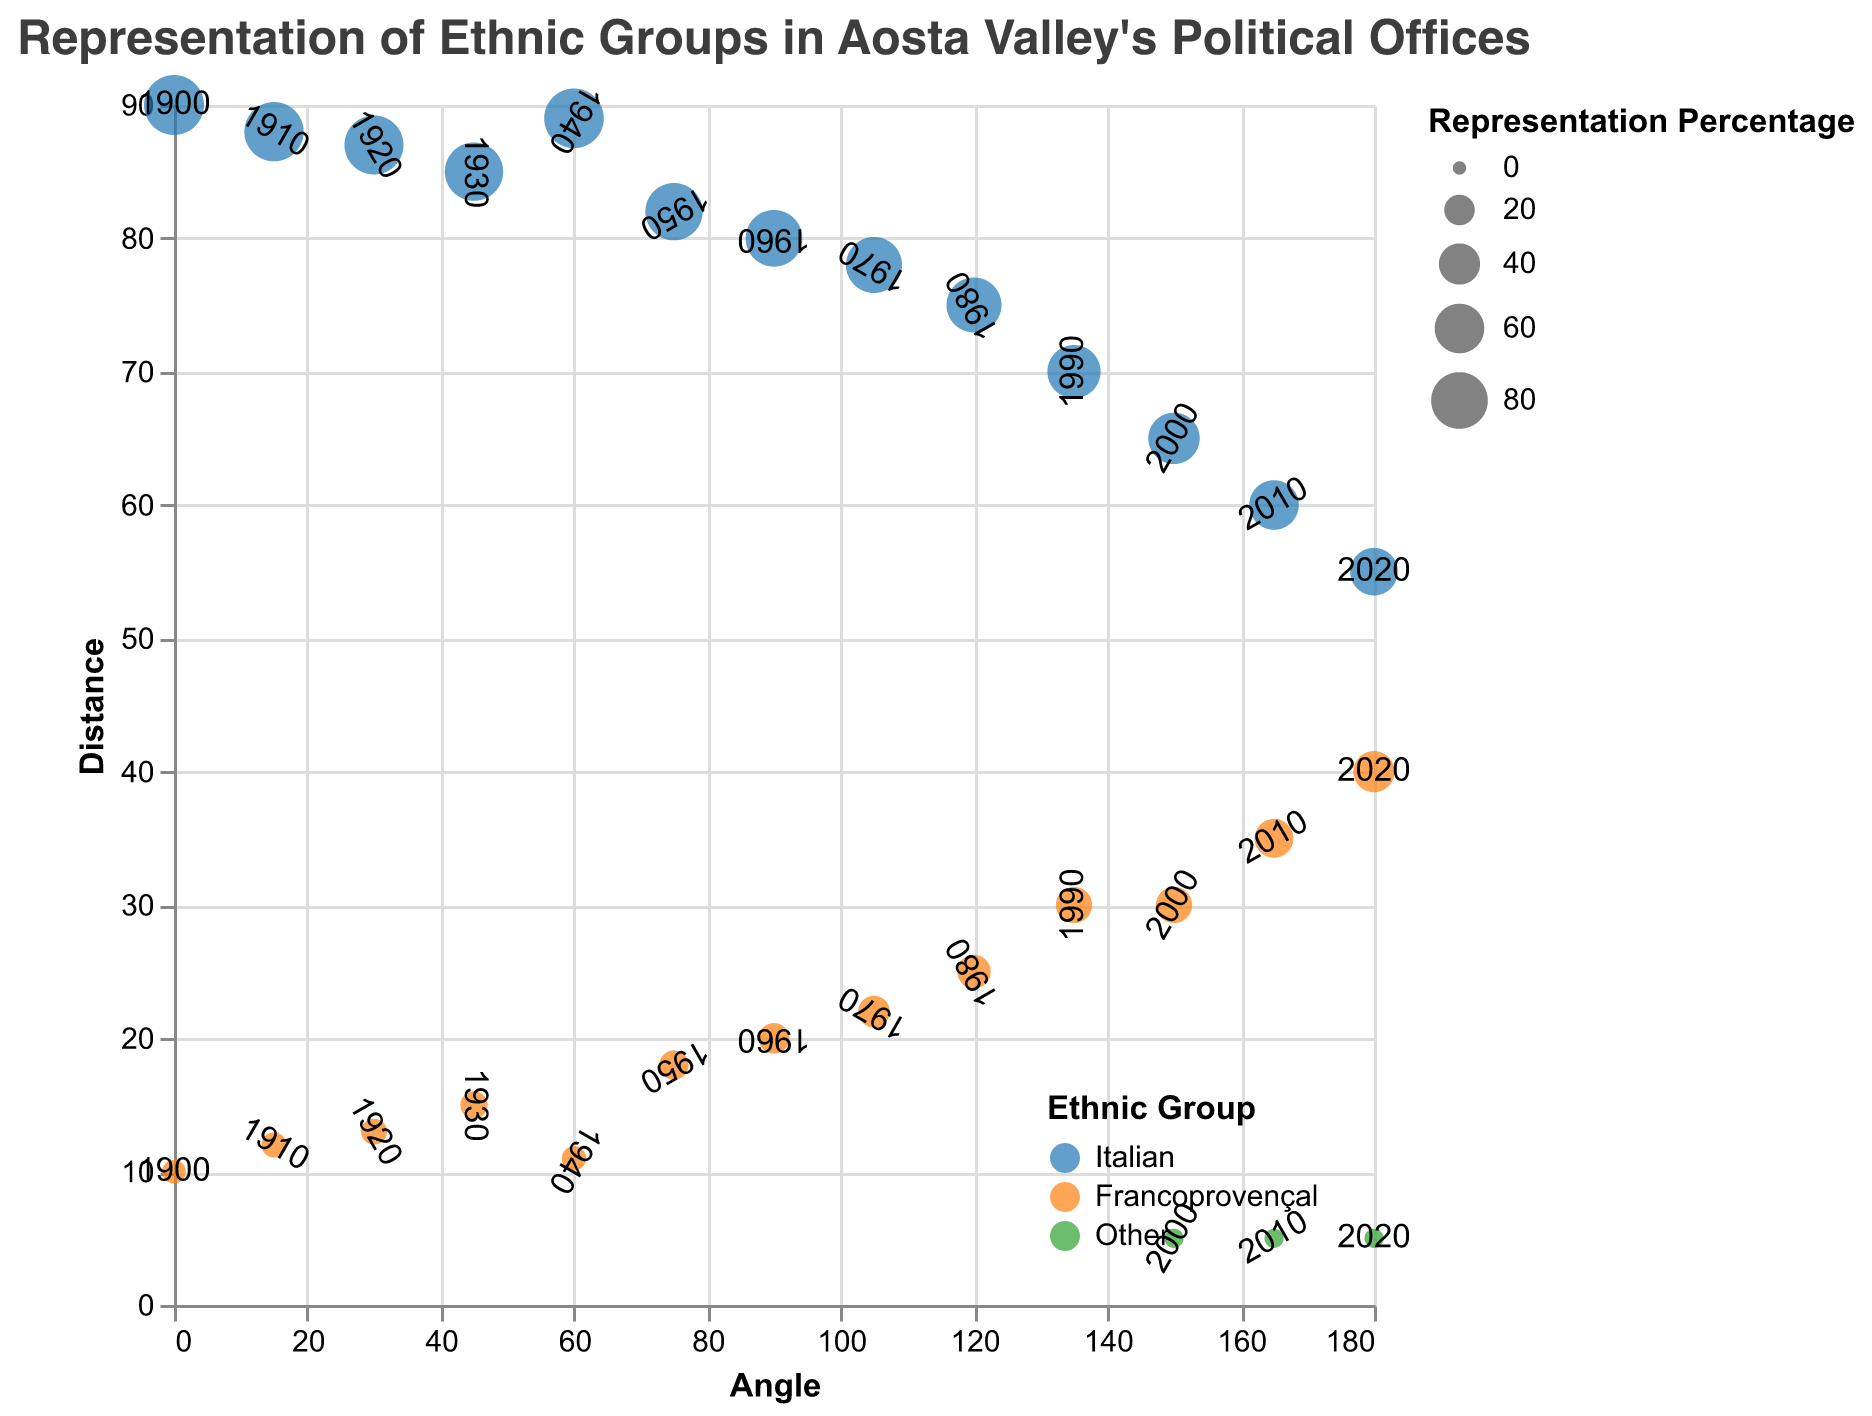What ethnic group had the highest representation percentage in 1900? Look at the data points at the angle corresponding to 1900 and identify the ethnic group with the highest distance from the origin. The Italian group is at 90%, while Francoprovençal is at 10%.
Answer: Italian How did the representation percentage of Francoprovençal change from 1960 to 2020? Examine the data points at the angles corresponding to 1960 and 2020. In 1960, the Francoprovençal group had 20%, and in 2020, it had 40%.
Answer: Increased What is the total representation percentage for all ethnic groups in 2000? Find the data points at the angle corresponding to 2000 and sum their percentages: Italian is 65%, Francoprovençal is 30%, and Other is 5%. Sum them up (65 + 30 + 5) = 100%.
Answer: 100% Which year had the highest representation for the 'Other' ethnic group and what was its percentage? Look for the data points for the 'Other' ethnic group and identify the year with the highest distance from the origin. The 'Other' group has 5% in both 2000, 2010, and 2020.
Answer: 2000, 2010, and 2020 all had 5% How did the representation of the Italian group change from 1910 to 1930? Examine the data points at the angles for the years 1910 and 1930. In 1910, the Italian group had 88%, and in 1930, it had 85%.
Answer: Decreased by 3% What is the average representation percentage of the Italian group between 1900 and 2020? Find all data points for the Italian group, sum their percentages, and divide by the number of data points. The percentages are 90, 88, 87, 85, 89, 82, 80, 78, 75, 70, 65, 60, 55. Sum them up (90 + 88 + 87 + 85 + 89 + 82 + 80 + 78 + 75 + 70 + 65 + 60 + 55) = 1024, then divide by 13 (the number of data points). 1024 / 13 ≈ 78.8.
Answer: 78.8% Between 1950 and 1980, which ethnic group saw a greater increase in representation percentage? Compare the representation percentages of both groups from 1950 to 1980. For Italian: 1950 is 82% and 1980 is 75%. For Francoprovençal: 1950 is 18% and 1980 is 25%. So, Italian decreased by 7%, Francoprovençal increased by 7%.
Answer: Francoprovençal Which ethnic group had the highest increase in representation percentage from 1900 to 2020? Compare the starting and ending percentages for each ethnic group from 1900 to 2020. Italian started at 90% and ended at 55% (decrease of 35%). Francoprovençal started at 10% and ended at 40% (increase of 30%). 'Other' started at 0% (assuming no presence) and ended at 5%.
Answer: Francoprovençal What was the representation percentage of Francoprovençal in 1990 compared to the Italian group in the same year? Examine the data points at the angle for 1990. Francoprovençal had 30%, and the Italian group had 70%.
Answer: Francoprovençal: 30%, Italian: 70% In which year did the Italian group's representation first fall below 80%? Find the first data point where the Italian group's percentage is below 80%. In 1960, it was 80%, and in 1970, it was 78%.
Answer: 1970 